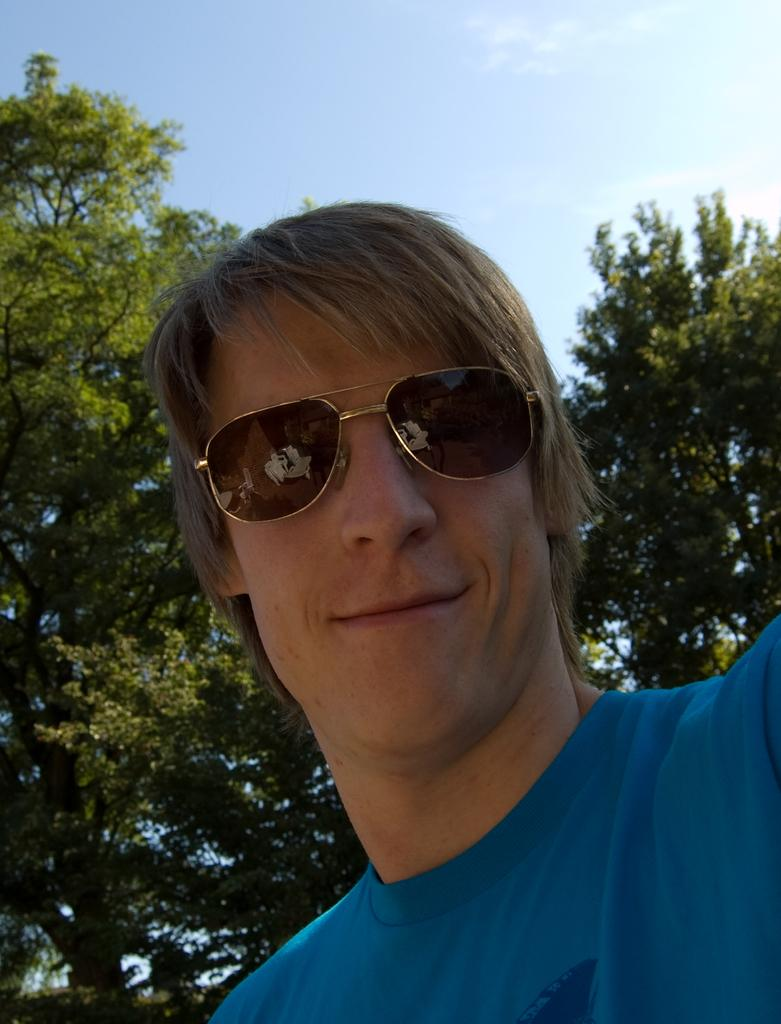Who is present in the image? There is a man in the picture. What is the man wearing on his face? The man is wearing goggles. What expression does the man have? The man is smiling. What can be seen in the background of the picture? There are trees and the sky visible in the background of the picture. What type of butter can be seen melting on the man's goggles in the image? There is no butter present in the image, and the man's goggles are not melting. 